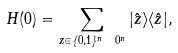<formula> <loc_0><loc_0><loc_500><loc_500>H ( 0 ) = \sum _ { z \in \{ 0 , 1 \} ^ { n } \ 0 ^ { n } } | \hat { z } \rangle \langle \hat { z } | ,</formula> 